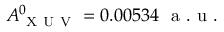<formula> <loc_0><loc_0><loc_500><loc_500>A _ { X U V } ^ { 0 } = 0 . 0 0 5 3 4 a . u .</formula> 